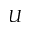<formula> <loc_0><loc_0><loc_500><loc_500>U</formula> 